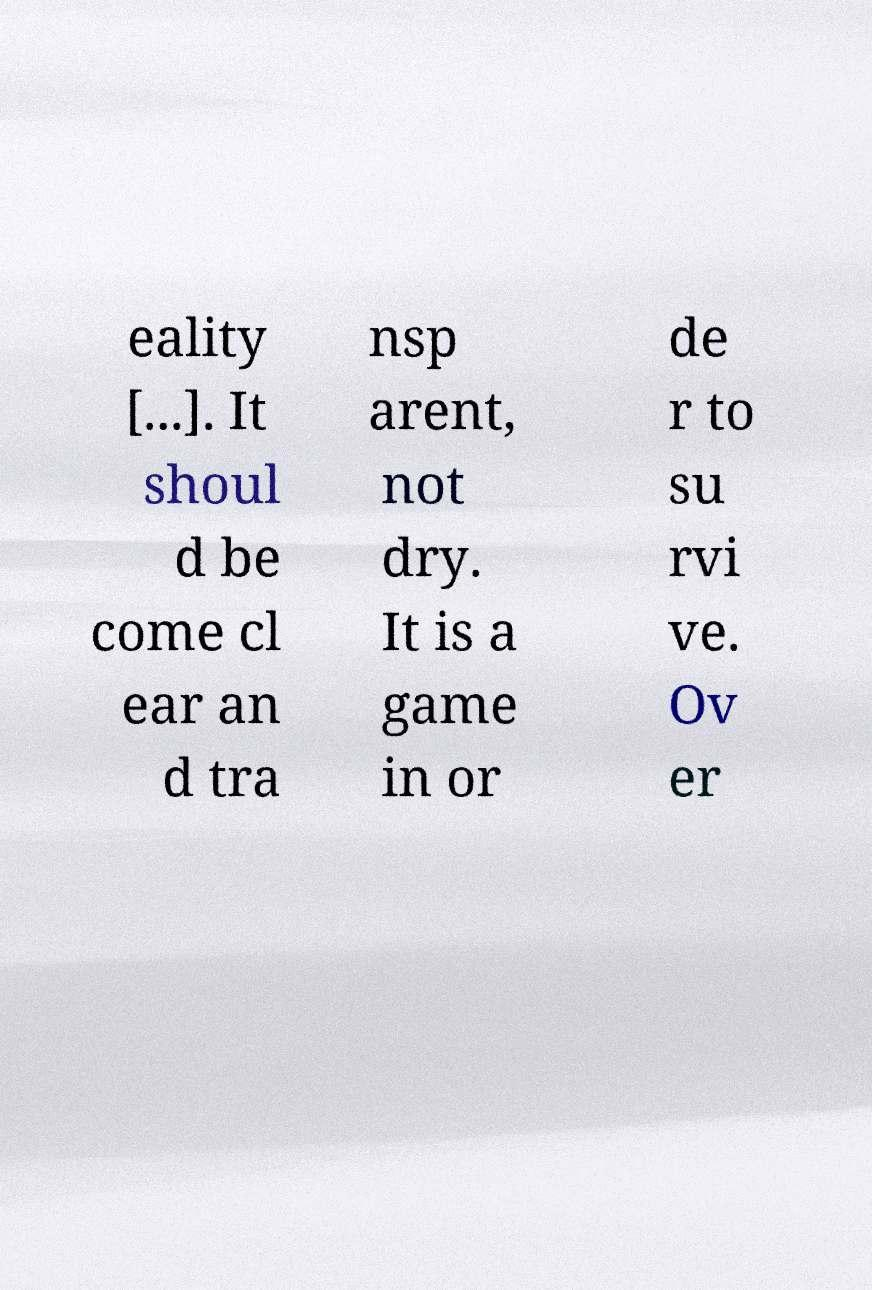Can you read and provide the text displayed in the image?This photo seems to have some interesting text. Can you extract and type it out for me? eality [...]. It shoul d be come cl ear an d tra nsp arent, not dry. It is a game in or de r to su rvi ve. Ov er 